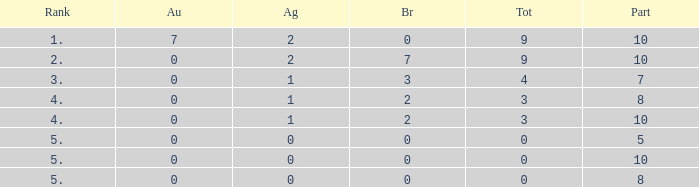What is listed as the highest Gold that also has a Silver that's smaller than 1, and has a Total that's smaller than 0? None. 